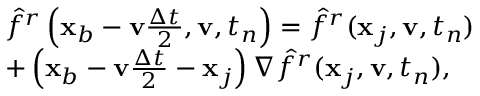Convert formula to latex. <formula><loc_0><loc_0><loc_500><loc_500>\begin{array} { r l } & { \hat { f } ^ { r } \left ( \mathbf x _ { b } - \mathbf v \frac { \Delta t } { 2 } , \mathbf v , t _ { n } \right ) = \hat { f } ^ { r } ( \mathbf x _ { j } , \mathbf v , t _ { n } ) } \\ & { + \left ( \mathbf x _ { b } - \mathbf v \frac { \Delta t } { 2 } - \mathbf x _ { j } \right ) \nabla \hat { f } ^ { r } ( \mathbf x _ { j } , \mathbf v , t _ { n } ) , } \end{array}</formula> 